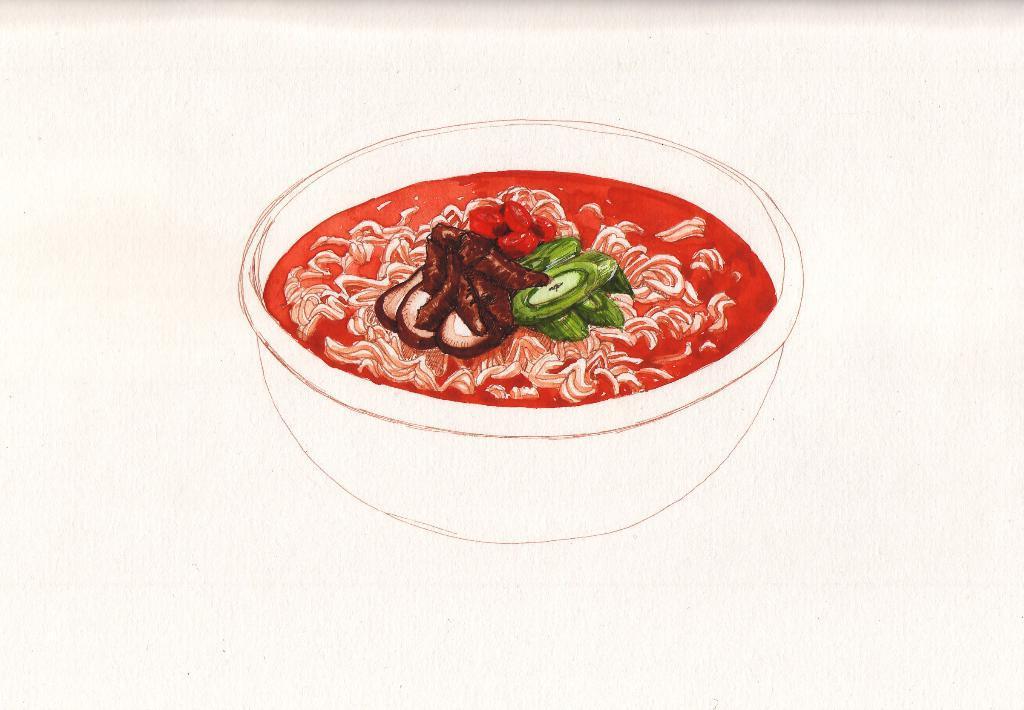Can you describe this image briefly? In this image there is a painting. In the painting we can see that there is a bowl. In the bowl there is some food which is in red color. 